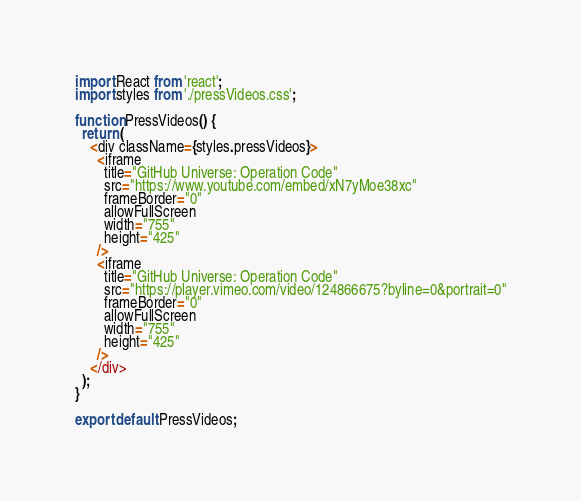Convert code to text. <code><loc_0><loc_0><loc_500><loc_500><_JavaScript_>import React from 'react';
import styles from './pressVideos.css';

function PressVideos() {
  return (
    <div className={styles.pressVideos}>
      <iframe
        title="GitHub Universe: Operation Code"
        src="https://www.youtube.com/embed/xN7yMoe38xc"
        frameBorder="0"
        allowFullScreen
        width="755"
        height="425"
      />
      <iframe
        title="GitHub Universe: Operation Code"
        src="https://player.vimeo.com/video/124866675?byline=0&portrait=0"
        frameBorder="0"
        allowFullScreen
        width="755"
        height="425"
      />
    </div>
  );
}

export default PressVideos;
</code> 